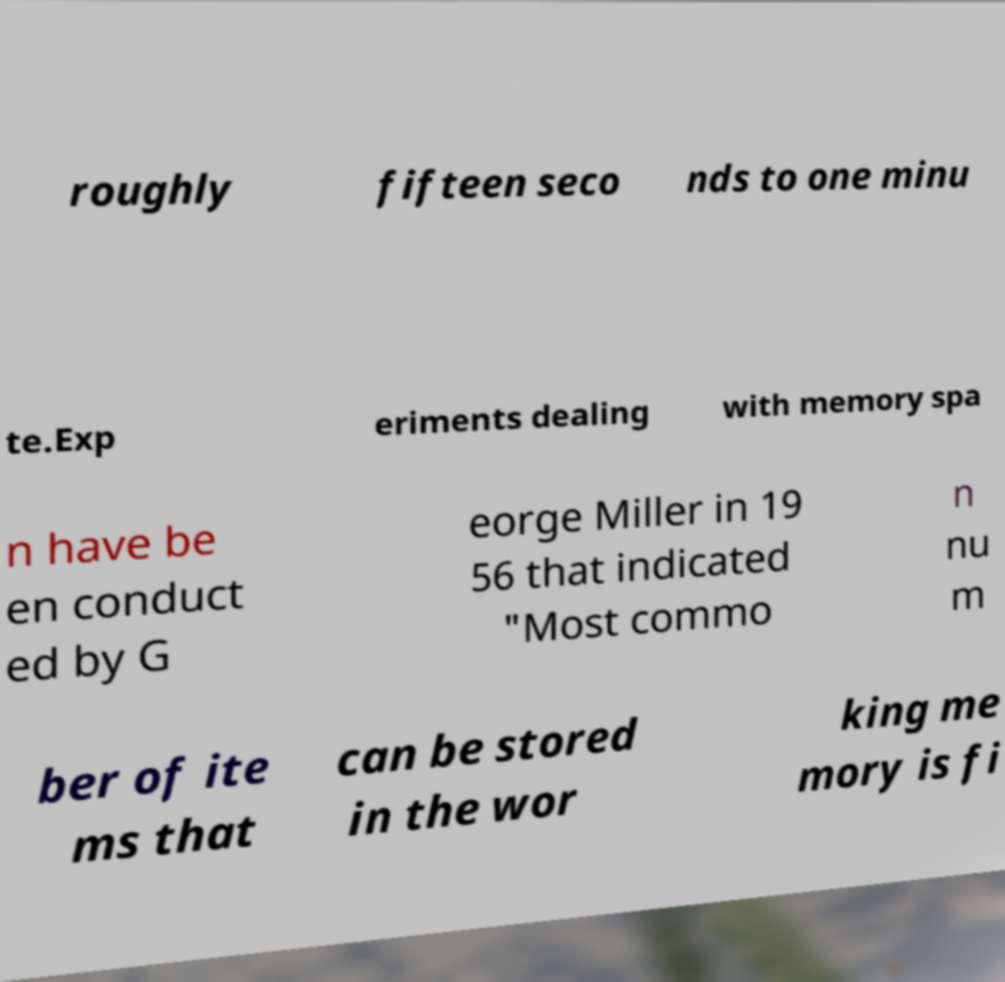What messages or text are displayed in this image? I need them in a readable, typed format. roughly fifteen seco nds to one minu te.Exp eriments dealing with memory spa n have be en conduct ed by G eorge Miller in 19 56 that indicated "Most commo n nu m ber of ite ms that can be stored in the wor king me mory is fi 